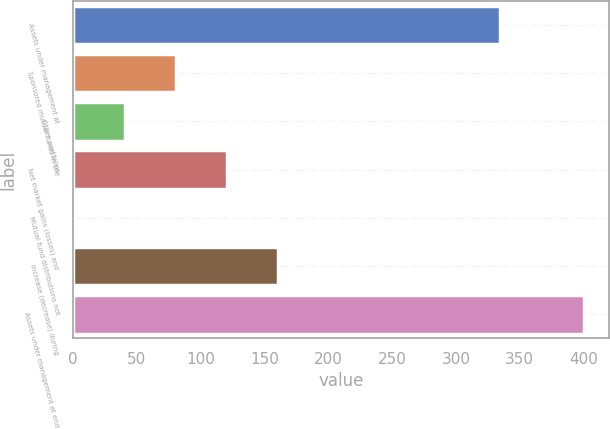Convert chart. <chart><loc_0><loc_0><loc_500><loc_500><bar_chart><fcel>Assets under management at<fcel>Sponsored mutual funds in the<fcel>Other portfolios<fcel>Net market gains (losses) and<fcel>Mutual fund distributions not<fcel>increase (decrease) during<fcel>Assets under management at end<nl><fcel>334.7<fcel>80.72<fcel>40.81<fcel>120.63<fcel>0.9<fcel>160.54<fcel>400<nl></chart> 